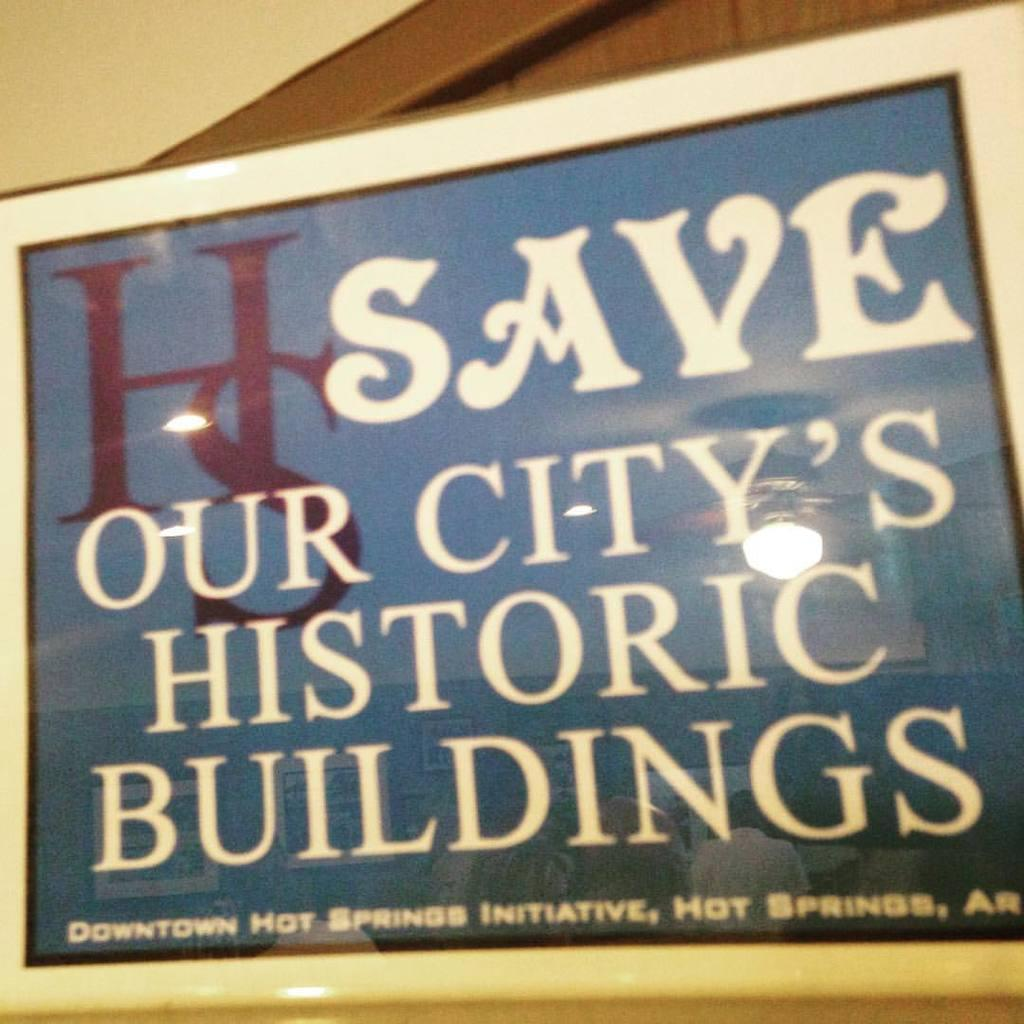<image>
Create a compact narrative representing the image presented. An outside sign that says HS Save our city's Historic Buildings in a blue background 